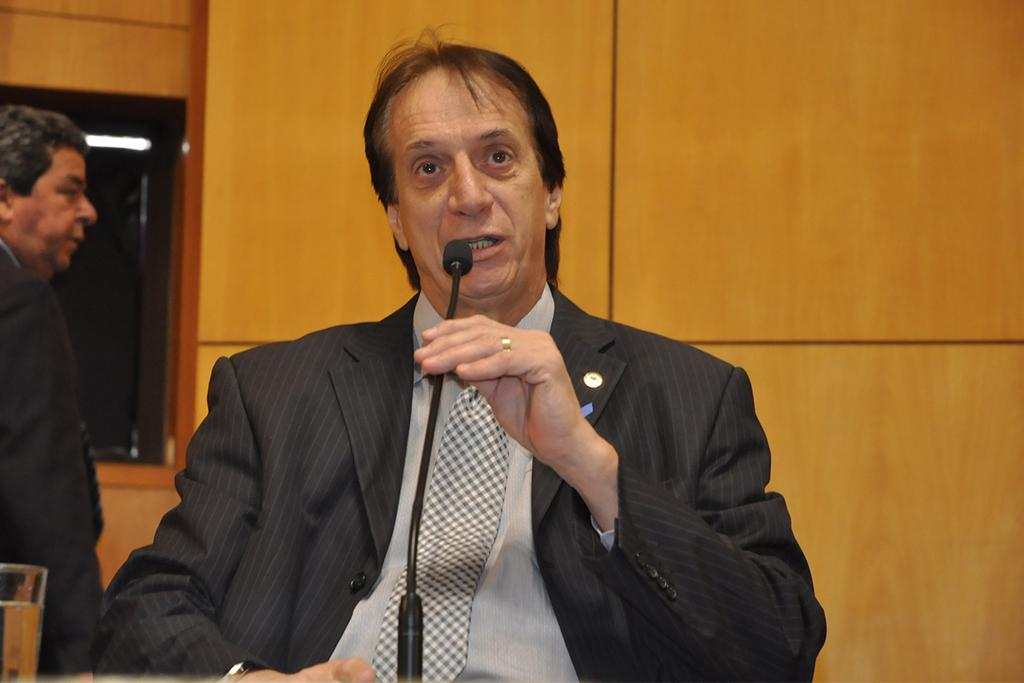Who is the main subject in the image? There is an old man in the image. What is the old man wearing? The old man is wearing a black suit. What is the old man holding in the image? The old man is holding a mic. What is the old man doing with the mic? The old man is talking on the mic. Can you describe the background of the image? There is a wooden wall in the background of the image. What type of chair is the donkey sitting on in the image? There is no donkey or chair present in the image. 